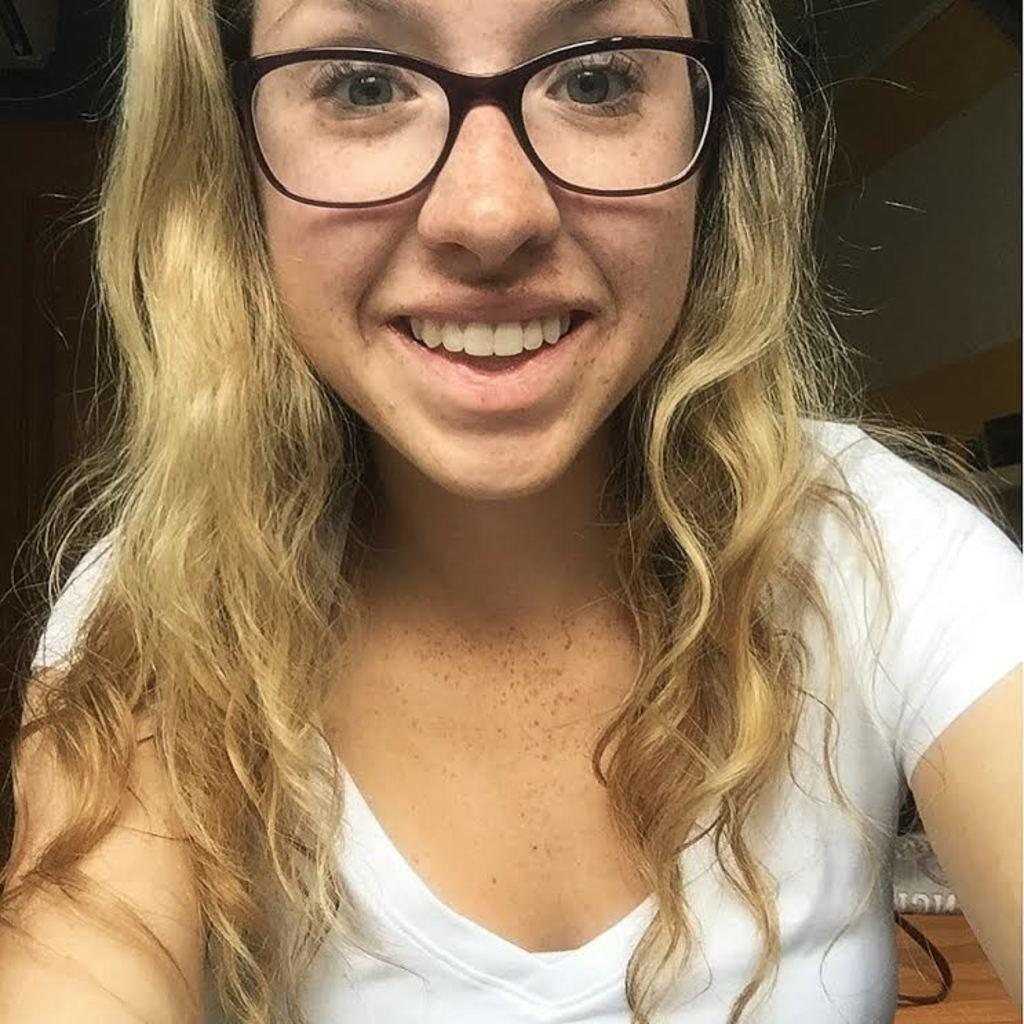Who is present in the image? There is a woman in the image. What is the woman wearing in the image? The woman is wearing spectacles in the image. What is the woman's facial expression in the image? The woman is smiling in the image. What type of food is the woman eating in the image? There is no food present in the image, so it cannot be determined what the woman might be eating. 